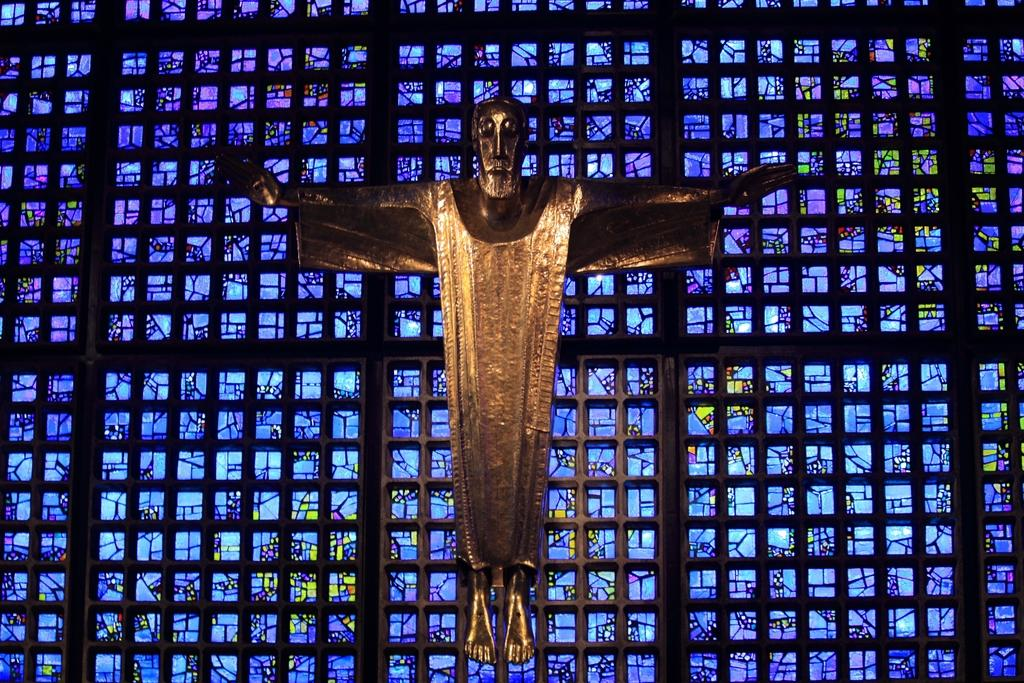What is the main subject of the image? There is a statue of a man in the image. What is the color of the statue? The statue is gold in color. What can be seen in the background of the image? A: There is a sheet in the background of the image. What colors are the sheet in the background? The sheet is blue and black in color. What type of quince is being used as a prop in the image? There is no quince present in the image. How many competitors are participating in the competition in the image? There is no competition depicted in the image. 